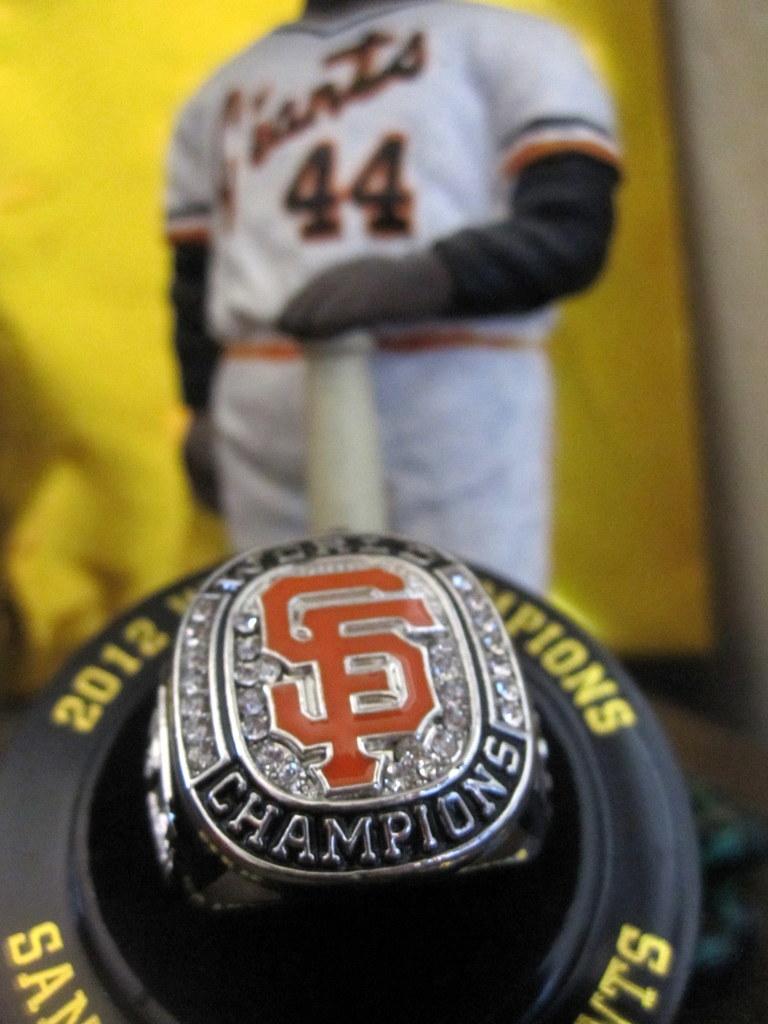What kind if ring is this?
Your response must be concise. Champions. 